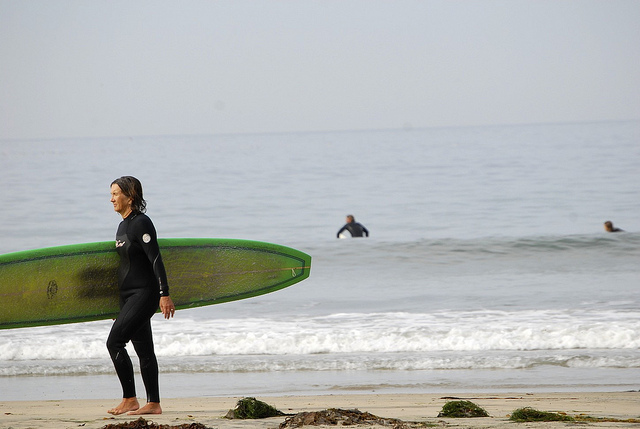What is the person in the foreground holding? The person in the foreground is holding a long, green surfboard. This individual appears to be preparing to enter the water or has just finished a surfing session, as indicated by the surfboard and the wetsuit they are wearing. 